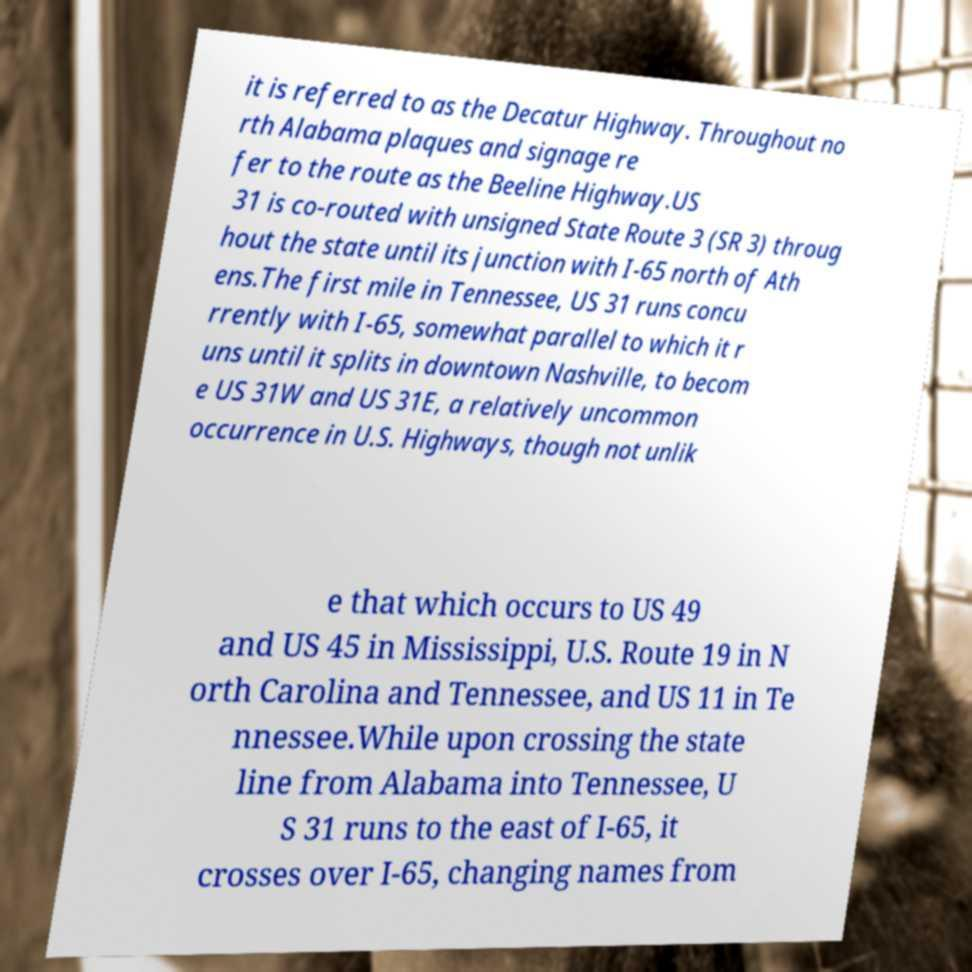For documentation purposes, I need the text within this image transcribed. Could you provide that? it is referred to as the Decatur Highway. Throughout no rth Alabama plaques and signage re fer to the route as the Beeline Highway.US 31 is co-routed with unsigned State Route 3 (SR 3) throug hout the state until its junction with I-65 north of Ath ens.The first mile in Tennessee, US 31 runs concu rrently with I-65, somewhat parallel to which it r uns until it splits in downtown Nashville, to becom e US 31W and US 31E, a relatively uncommon occurrence in U.S. Highways, though not unlik e that which occurs to US 49 and US 45 in Mississippi, U.S. Route 19 in N orth Carolina and Tennessee, and US 11 in Te nnessee.While upon crossing the state line from Alabama into Tennessee, U S 31 runs to the east of I-65, it crosses over I-65, changing names from 